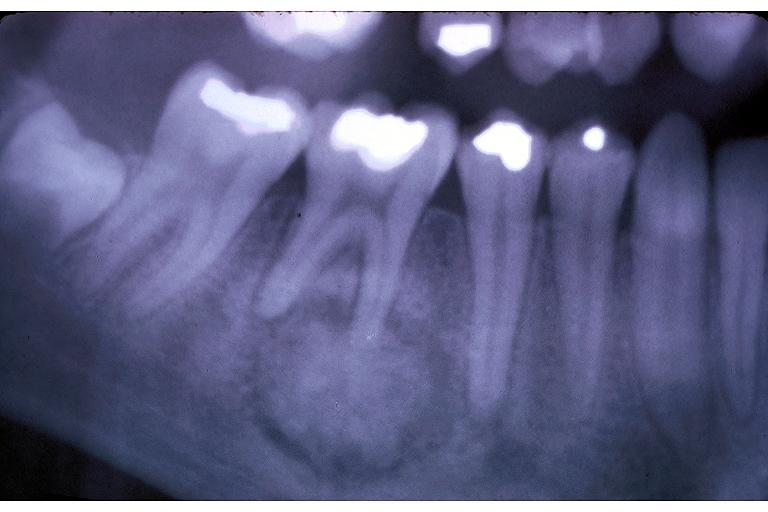does this image show cementoblastoma?
Answer the question using a single word or phrase. Yes 